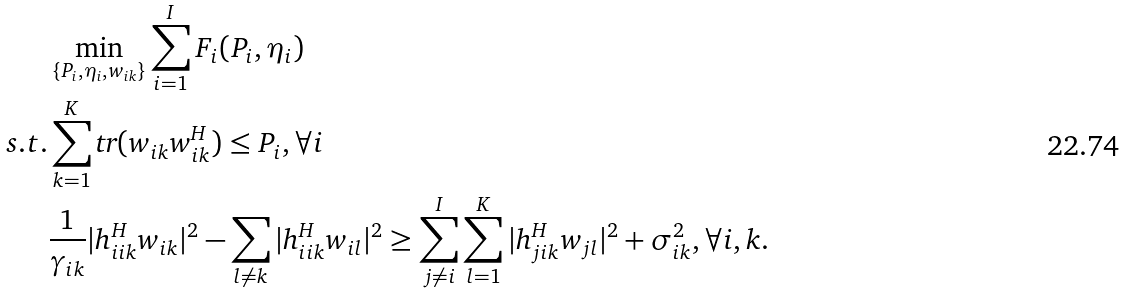Convert formula to latex. <formula><loc_0><loc_0><loc_500><loc_500>& \min _ { \{ P _ { i } , \eta _ { i } , w _ { i k } \} } \sum _ { i = 1 } ^ { I } F _ { i } ( P _ { i } , \eta _ { i } ) \\ s . t . & \sum _ { k = 1 } ^ { K } \text {tr} ( w _ { i k } w _ { i k } ^ { H } ) \leq P _ { i } , \forall i \\ & \frac { 1 } { \gamma _ { i k } } | h _ { i i k } ^ { H } w _ { i k } | ^ { 2 } - \sum _ { l \neq k } | h _ { i i k } ^ { H } w _ { i l } | ^ { 2 } \geq \sum _ { j \neq i } ^ { I } \sum _ { l = 1 } ^ { K } { | h _ { j i k } ^ { H } w _ { j l } } | ^ { 2 } + \sigma _ { i k } ^ { 2 } , \forall i , k .</formula> 